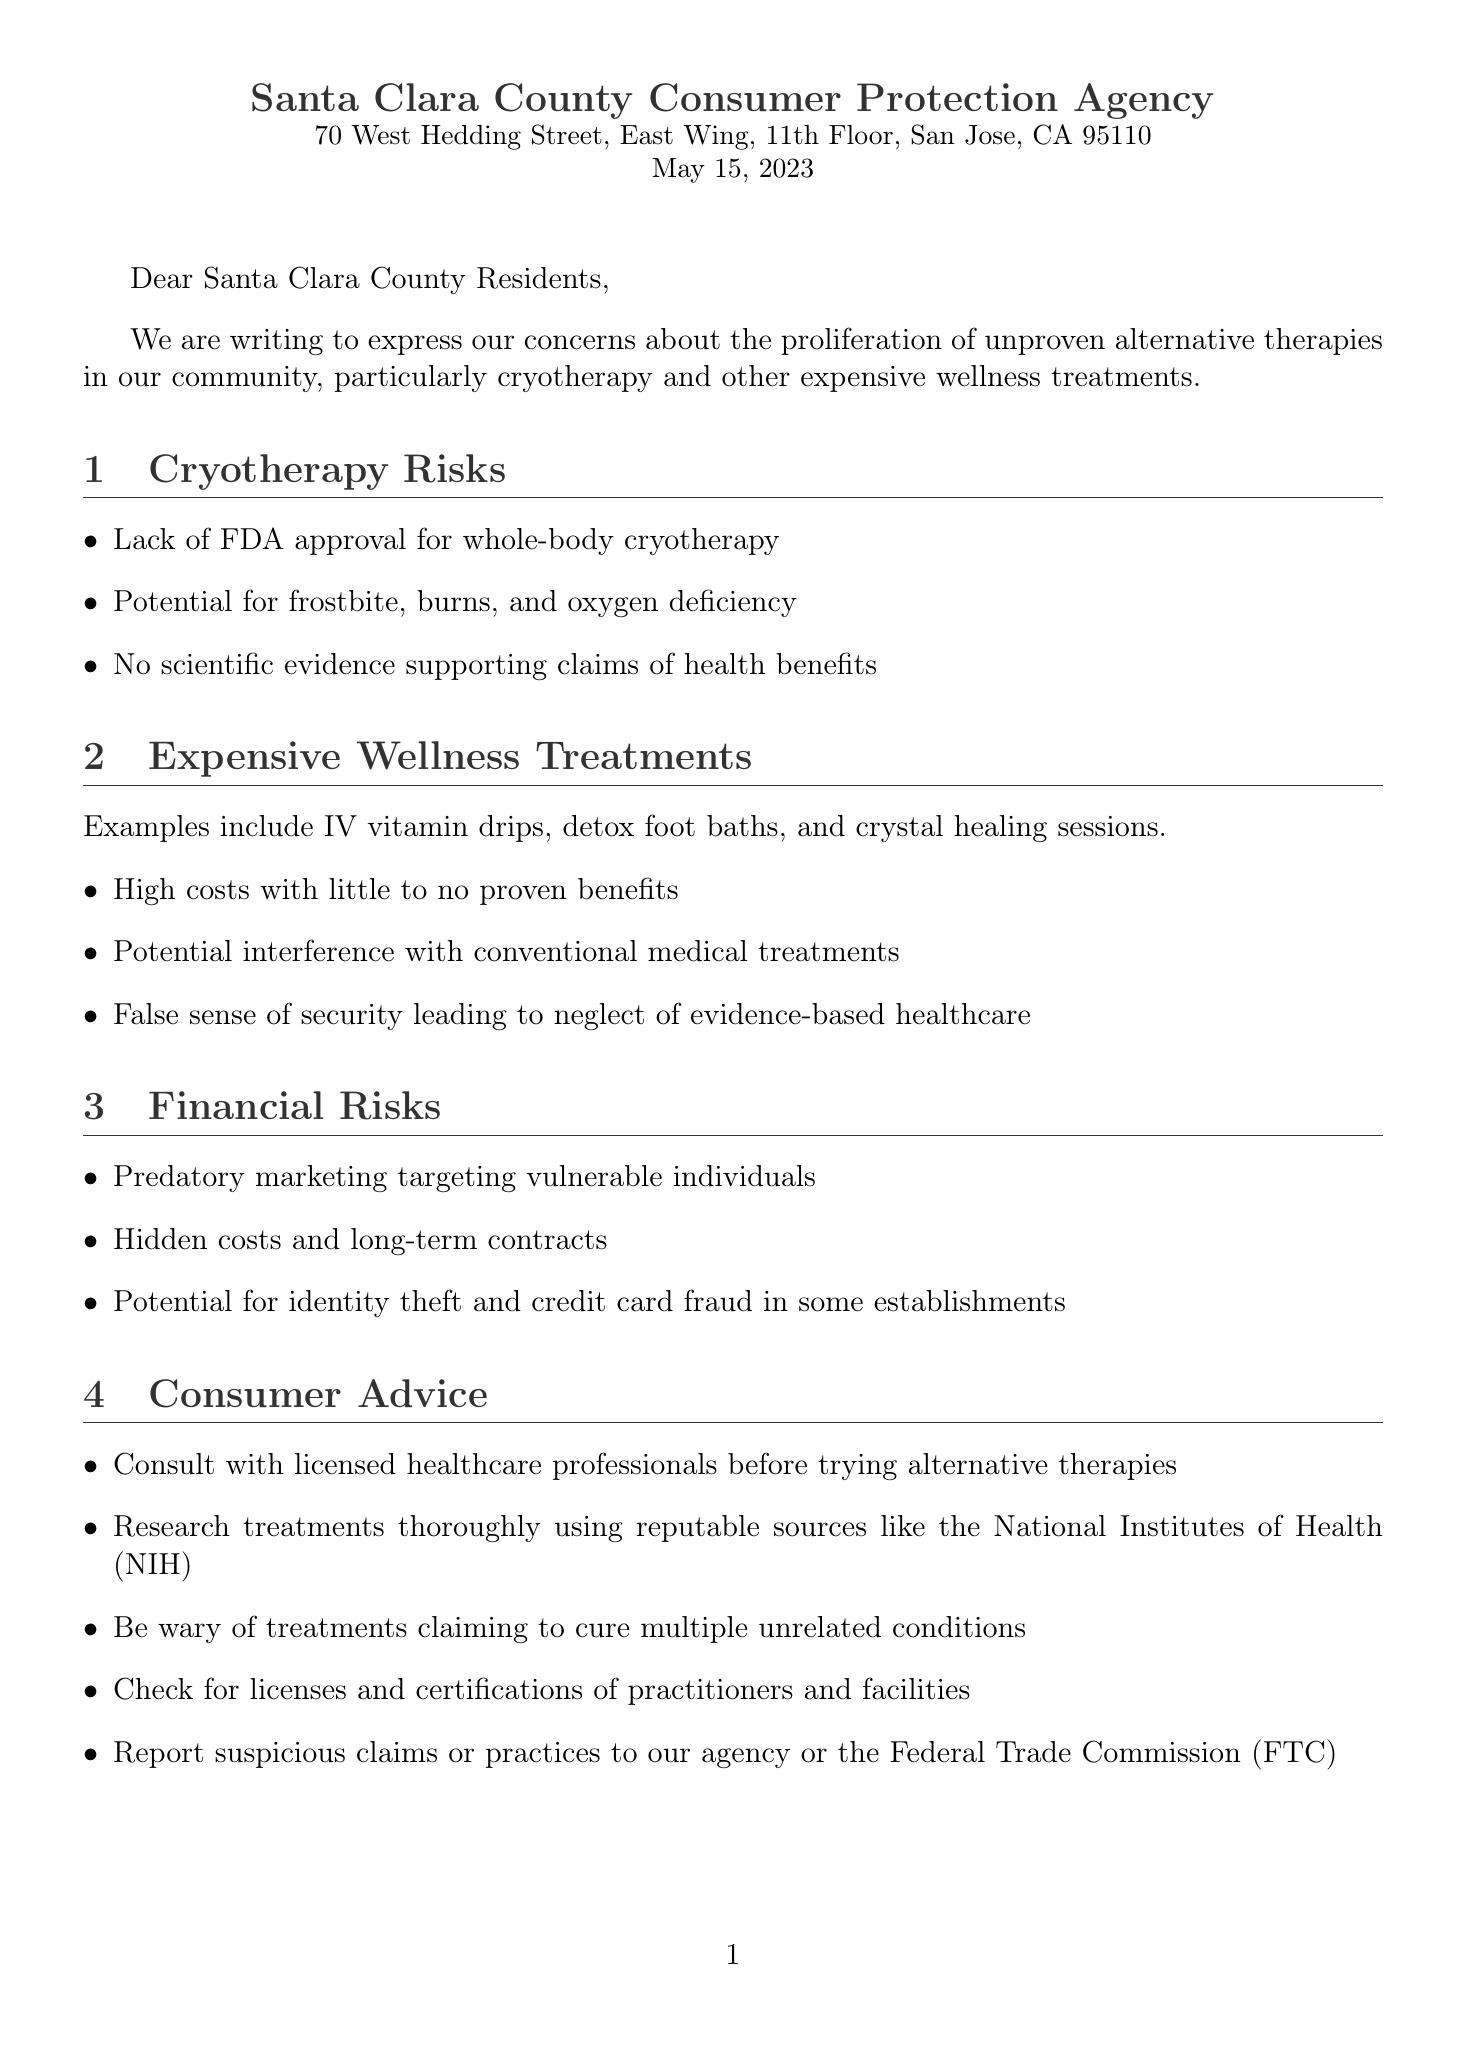What is the name of the agency? The agency's name is at the beginning of the document as "Santa Clara County Consumer Protection Agency."
Answer: Santa Clara County Consumer Protection Agency What is the address of the agency? The address is included in the letter header where the agency is located.
Answer: 70 West Hedding Street, East Wing, 11th Floor, San Jose, CA 95110 What is the date of the letter? The date is clearly stated at the top of the letter.
Answer: May 15, 2023 What are examples of expensive wellness treatments mentioned? The letter lists specific examples in the section about expensive wellness treatments, such as IV vitamin drips.
Answer: IV vitamin drips What warning is provided regarding cryotherapy? The document specifies certain risks associated with cryotherapy that are highlighted in the corresponding section.
Answer: Frostbite, burns, and oxygen deficiency Why should consumers consult licensed healthcare professionals? Consulting licensed healthcare professionals is suggested in the consumer advice section for safety regarding alternative therapies.
Answer: For safety What is a cautionary tale mentioned in the letter? The letter includes a case study that serves as an example of the dangers associated with unproven therapies.
Answer: The Theranos Scandal Who signed the letter? The closing of the letter mentions the individual who signed it with their title.
Answer: Maria Rodriguez What is one resource listed for additional information? The additional resources section specifies credible places where consumers can seek more information.
Answer: www.ftc.gov/health 